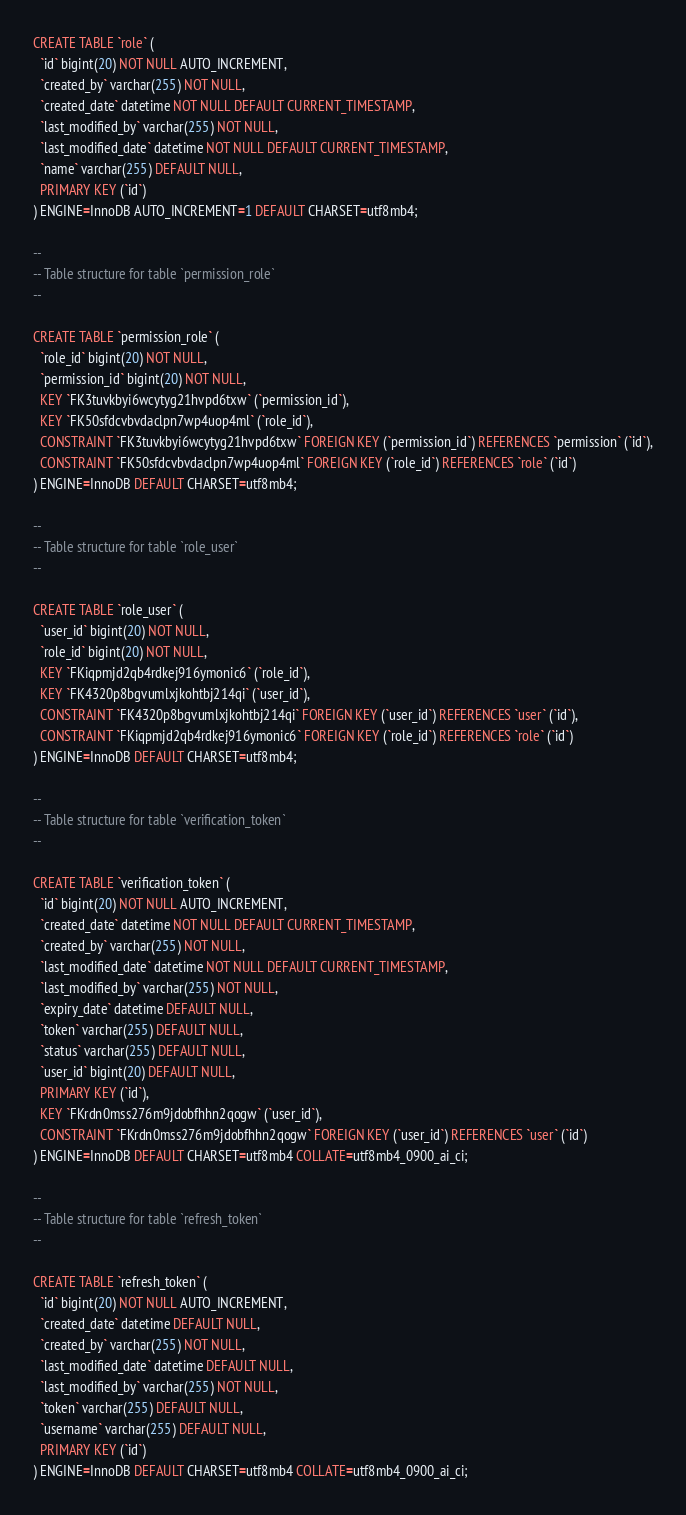Convert code to text. <code><loc_0><loc_0><loc_500><loc_500><_SQL_>
CREATE TABLE `role` (
  `id` bigint(20) NOT NULL AUTO_INCREMENT,
  `created_by` varchar(255) NOT NULL,
  `created_date` datetime NOT NULL DEFAULT CURRENT_TIMESTAMP,
  `last_modified_by` varchar(255) NOT NULL,
  `last_modified_date` datetime NOT NULL DEFAULT CURRENT_TIMESTAMP,
  `name` varchar(255) DEFAULT NULL,
  PRIMARY KEY (`id`)
) ENGINE=InnoDB AUTO_INCREMENT=1 DEFAULT CHARSET=utf8mb4;

--
-- Table structure for table `permission_role`
--

CREATE TABLE `permission_role` (
  `role_id` bigint(20) NOT NULL,
  `permission_id` bigint(20) NOT NULL,
  KEY `FK3tuvkbyi6wcytyg21hvpd6txw` (`permission_id`),
  KEY `FK50sfdcvbvdaclpn7wp4uop4ml` (`role_id`),
  CONSTRAINT `FK3tuvkbyi6wcytyg21hvpd6txw` FOREIGN KEY (`permission_id`) REFERENCES `permission` (`id`),
  CONSTRAINT `FK50sfdcvbvdaclpn7wp4uop4ml` FOREIGN KEY (`role_id`) REFERENCES `role` (`id`)
) ENGINE=InnoDB DEFAULT CHARSET=utf8mb4; 

--
-- Table structure for table `role_user`
--

CREATE TABLE `role_user` (
  `user_id` bigint(20) NOT NULL,
  `role_id` bigint(20) NOT NULL,
  KEY `FKiqpmjd2qb4rdkej916ymonic6` (`role_id`),
  KEY `FK4320p8bgvumlxjkohtbj214qi` (`user_id`),
  CONSTRAINT `FK4320p8bgvumlxjkohtbj214qi` FOREIGN KEY (`user_id`) REFERENCES `user` (`id`),
  CONSTRAINT `FKiqpmjd2qb4rdkej916ymonic6` FOREIGN KEY (`role_id`) REFERENCES `role` (`id`)
) ENGINE=InnoDB DEFAULT CHARSET=utf8mb4;

--
-- Table structure for table `verification_token`
--

CREATE TABLE `verification_token` (
  `id` bigint(20) NOT NULL AUTO_INCREMENT,
  `created_date` datetime NOT NULL DEFAULT CURRENT_TIMESTAMP,
  `created_by` varchar(255) NOT NULL,
  `last_modified_date` datetime NOT NULL DEFAULT CURRENT_TIMESTAMP,
  `last_modified_by` varchar(255) NOT NULL,
  `expiry_date` datetime DEFAULT NULL,
  `token` varchar(255) DEFAULT NULL,
  `status` varchar(255) DEFAULT NULL,
  `user_id` bigint(20) DEFAULT NULL,
  PRIMARY KEY (`id`),
  KEY `FKrdn0mss276m9jdobfhhn2qogw` (`user_id`),
  CONSTRAINT `FKrdn0mss276m9jdobfhhn2qogw` FOREIGN KEY (`user_id`) REFERENCES `user` (`id`)
) ENGINE=InnoDB DEFAULT CHARSET=utf8mb4 COLLATE=utf8mb4_0900_ai_ci;

--
-- Table structure for table `refresh_token`
--

CREATE TABLE `refresh_token` (
  `id` bigint(20) NOT NULL AUTO_INCREMENT,
  `created_date` datetime DEFAULT NULL,
  `created_by` varchar(255) NOT NULL,
  `last_modified_date` datetime DEFAULT NULL,
  `last_modified_by` varchar(255) NOT NULL,
  `token` varchar(255) DEFAULT NULL,
  `username` varchar(255) DEFAULT NULL,
  PRIMARY KEY (`id`)
) ENGINE=InnoDB DEFAULT CHARSET=utf8mb4 COLLATE=utf8mb4_0900_ai_ci;</code> 